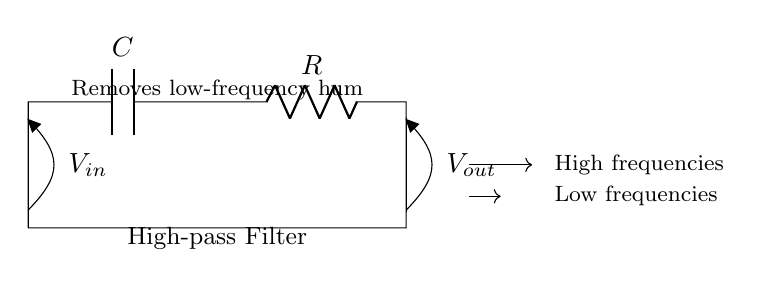What is the purpose of this circuit? The circuit is a high-pass filter designed to remove low-frequency hum, allowing high-frequency signals to pass through.
Answer: remove low-frequency hum What components are present in the circuit? The circuit contains a capacitor labeled C and a resistor labeled R. These components are essential for the high-pass filtering action.
Answer: capacitor and resistor What is the input voltage in the circuit? The input voltage is denoted as V-in, which indicates the voltage applied to the circuit before processing.
Answer: V-in What type of filter is depicted in the circuit? The circuit is identified as a high-pass filter, as indicated by the labeling and its function of allowing high frequencies to pass while attenuating low frequencies.
Answer: high-pass filter What happens to low frequencies in this circuit? Low frequencies are attenuated or blocked by the high-pass filter, preventing them from reaching the output.
Answer: attenuated What is the voltage at the output terminal when high frequencies are present? The output voltage is V-out, which represents the voltage after the high frequencies have passed through the filter.
Answer: V-out What characteristic does this filter have regarding frequency response? The filter allows high frequencies to pass through while blocking low frequencies, demonstrating a characteristic frequency response typical of high-pass filters.
Answer: blocks low frequencies 